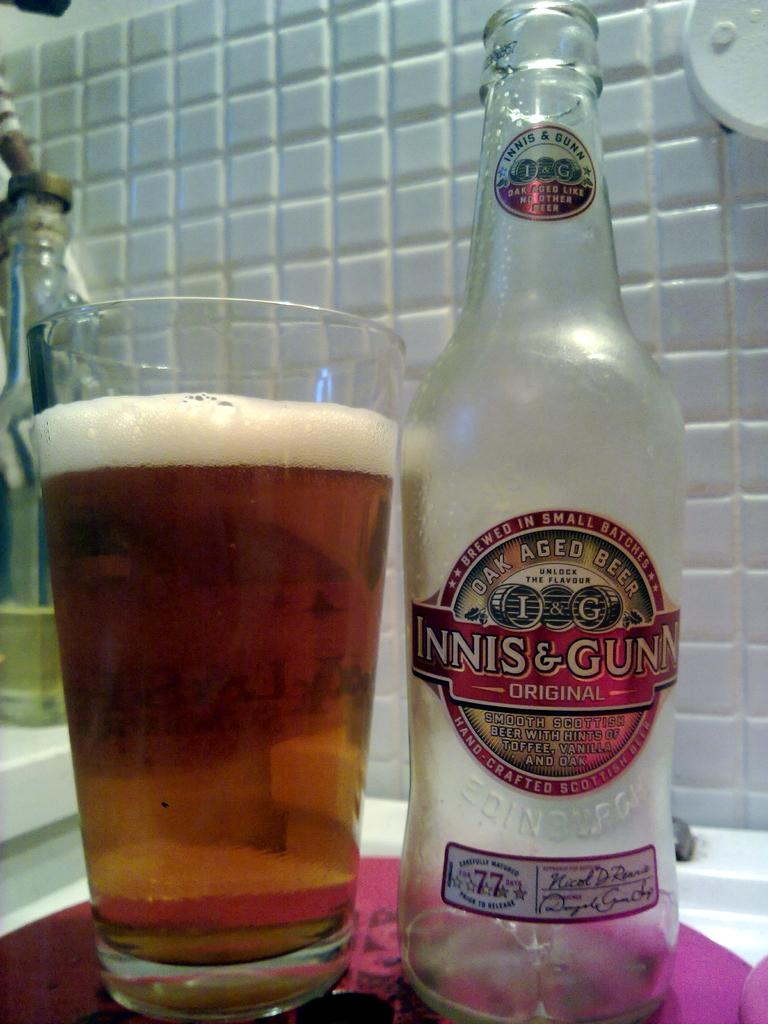Provide a one-sentence caption for the provided image. Bottle of Innis & Gunn next to a full cup of beer. 